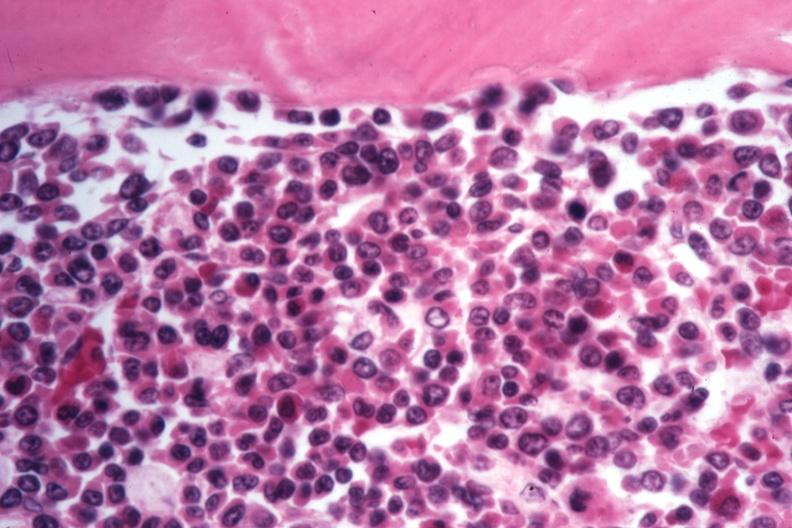s leg present?
Answer the question using a single word or phrase. No 